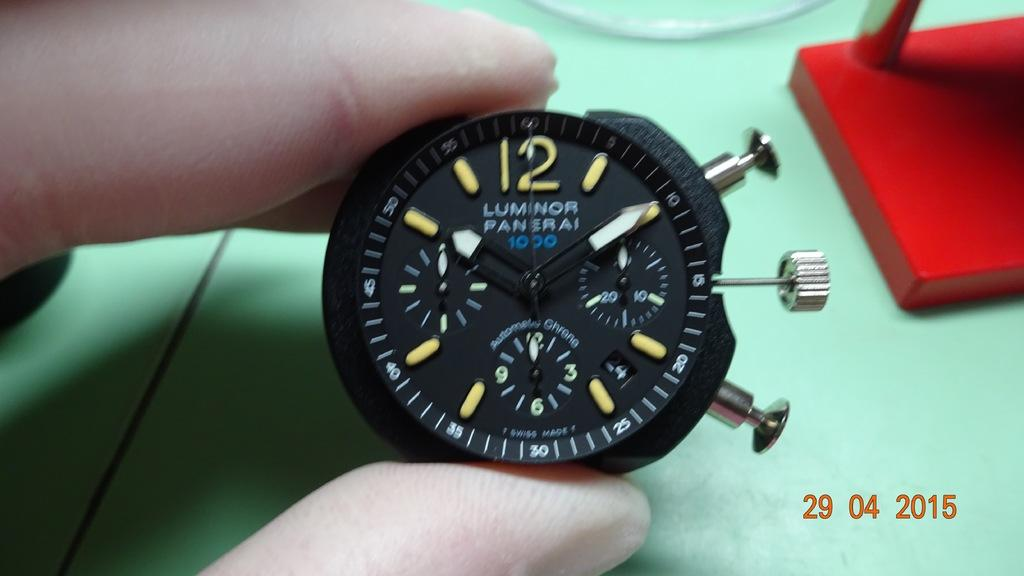<image>
Create a compact narrative representing the image presented. The number 12 is to be seen on the face of a stopwatch 